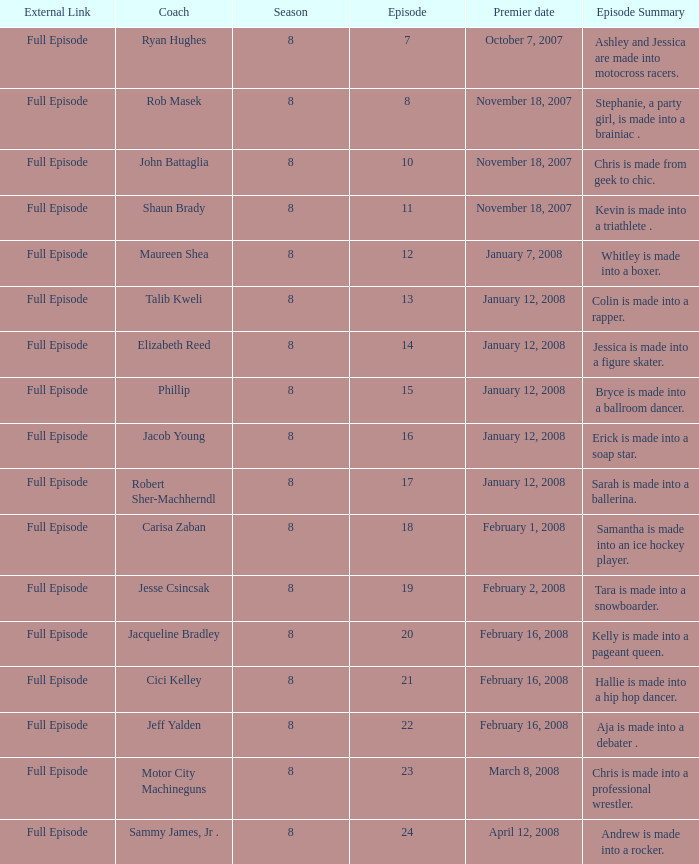Which Maximum episode premiered March 8, 2008? 23.0. 